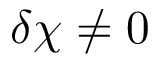Convert formula to latex. <formula><loc_0><loc_0><loc_500><loc_500>\delta \chi \neq 0</formula> 